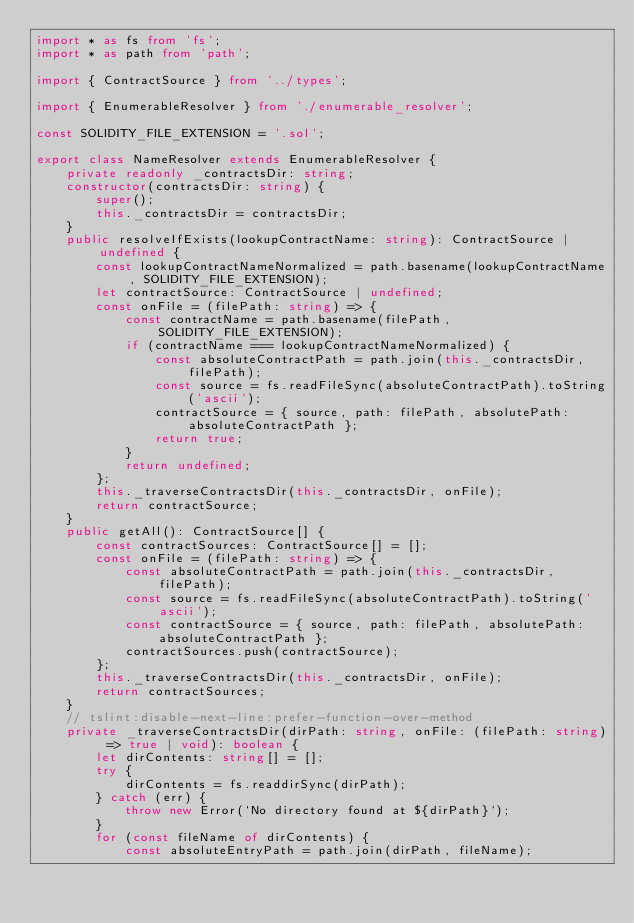<code> <loc_0><loc_0><loc_500><loc_500><_TypeScript_>import * as fs from 'fs';
import * as path from 'path';

import { ContractSource } from '../types';

import { EnumerableResolver } from './enumerable_resolver';

const SOLIDITY_FILE_EXTENSION = '.sol';

export class NameResolver extends EnumerableResolver {
    private readonly _contractsDir: string;
    constructor(contractsDir: string) {
        super();
        this._contractsDir = contractsDir;
    }
    public resolveIfExists(lookupContractName: string): ContractSource | undefined {
        const lookupContractNameNormalized = path.basename(lookupContractName, SOLIDITY_FILE_EXTENSION);
        let contractSource: ContractSource | undefined;
        const onFile = (filePath: string) => {
            const contractName = path.basename(filePath, SOLIDITY_FILE_EXTENSION);
            if (contractName === lookupContractNameNormalized) {
                const absoluteContractPath = path.join(this._contractsDir, filePath);
                const source = fs.readFileSync(absoluteContractPath).toString('ascii');
                contractSource = { source, path: filePath, absolutePath: absoluteContractPath };
                return true;
            }
            return undefined;
        };
        this._traverseContractsDir(this._contractsDir, onFile);
        return contractSource;
    }
    public getAll(): ContractSource[] {
        const contractSources: ContractSource[] = [];
        const onFile = (filePath: string) => {
            const absoluteContractPath = path.join(this._contractsDir, filePath);
            const source = fs.readFileSync(absoluteContractPath).toString('ascii');
            const contractSource = { source, path: filePath, absolutePath: absoluteContractPath };
            contractSources.push(contractSource);
        };
        this._traverseContractsDir(this._contractsDir, onFile);
        return contractSources;
    }
    // tslint:disable-next-line:prefer-function-over-method
    private _traverseContractsDir(dirPath: string, onFile: (filePath: string) => true | void): boolean {
        let dirContents: string[] = [];
        try {
            dirContents = fs.readdirSync(dirPath);
        } catch (err) {
            throw new Error(`No directory found at ${dirPath}`);
        }
        for (const fileName of dirContents) {
            const absoluteEntryPath = path.join(dirPath, fileName);</code> 